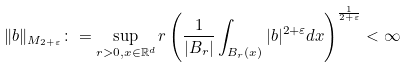<formula> <loc_0><loc_0><loc_500><loc_500>\| b \| _ { M _ { 2 + \varepsilon } } \colon = \sup _ { r > 0 , x \in \mathbb { R } ^ { d } } r \left ( \frac { 1 } { | B _ { r } | } \int _ { B _ { r } ( x ) } | b | ^ { 2 + \varepsilon } d x \right ) ^ { \frac { 1 } { 2 + \varepsilon } } < \infty</formula> 